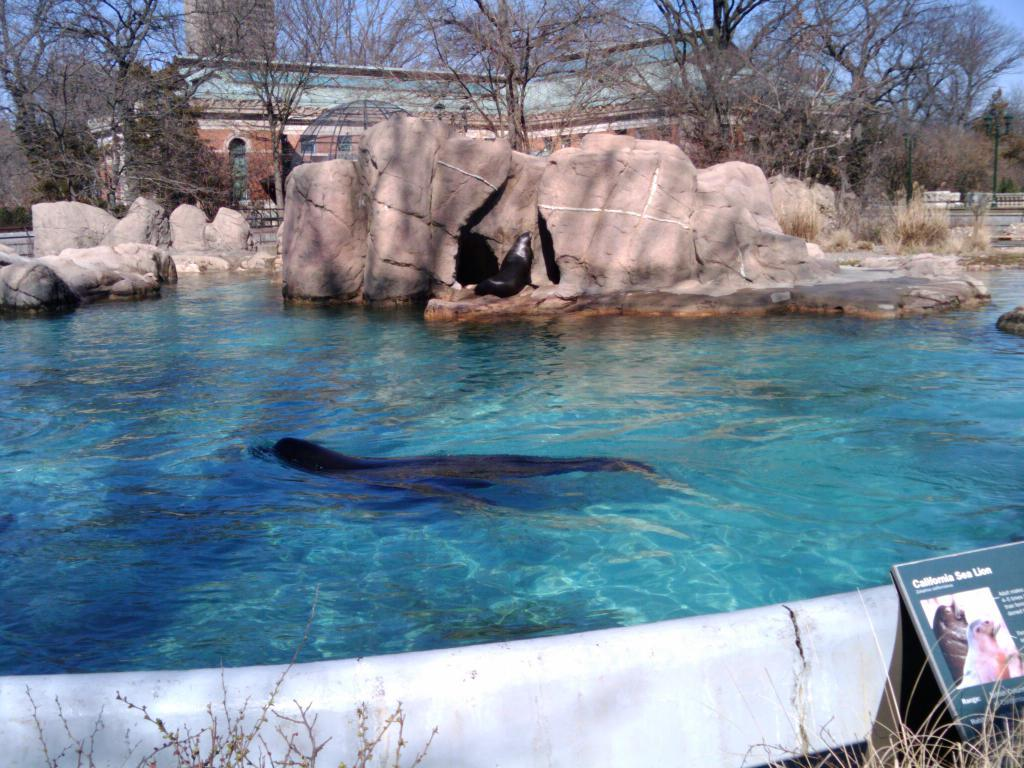What animals can be seen in the water in the image? There are seals swimming in the water in the image. What type of vegetation is visible in the image? There are trees visible in the image. What type of structure can be seen in the image? There appears to be a house in the image. Where is the image of the seals located in the image? The image of the seals is on the right side of the image. What type of joke can be seen in the image? There is no joke present in the image; it features seals swimming in the water, trees, a house, and an image of the seals. Can you tell me how many attempts the seals made to play chess in the image? There is no chess or indication of any attempts to play chess in the image. 